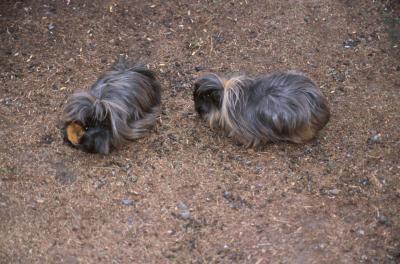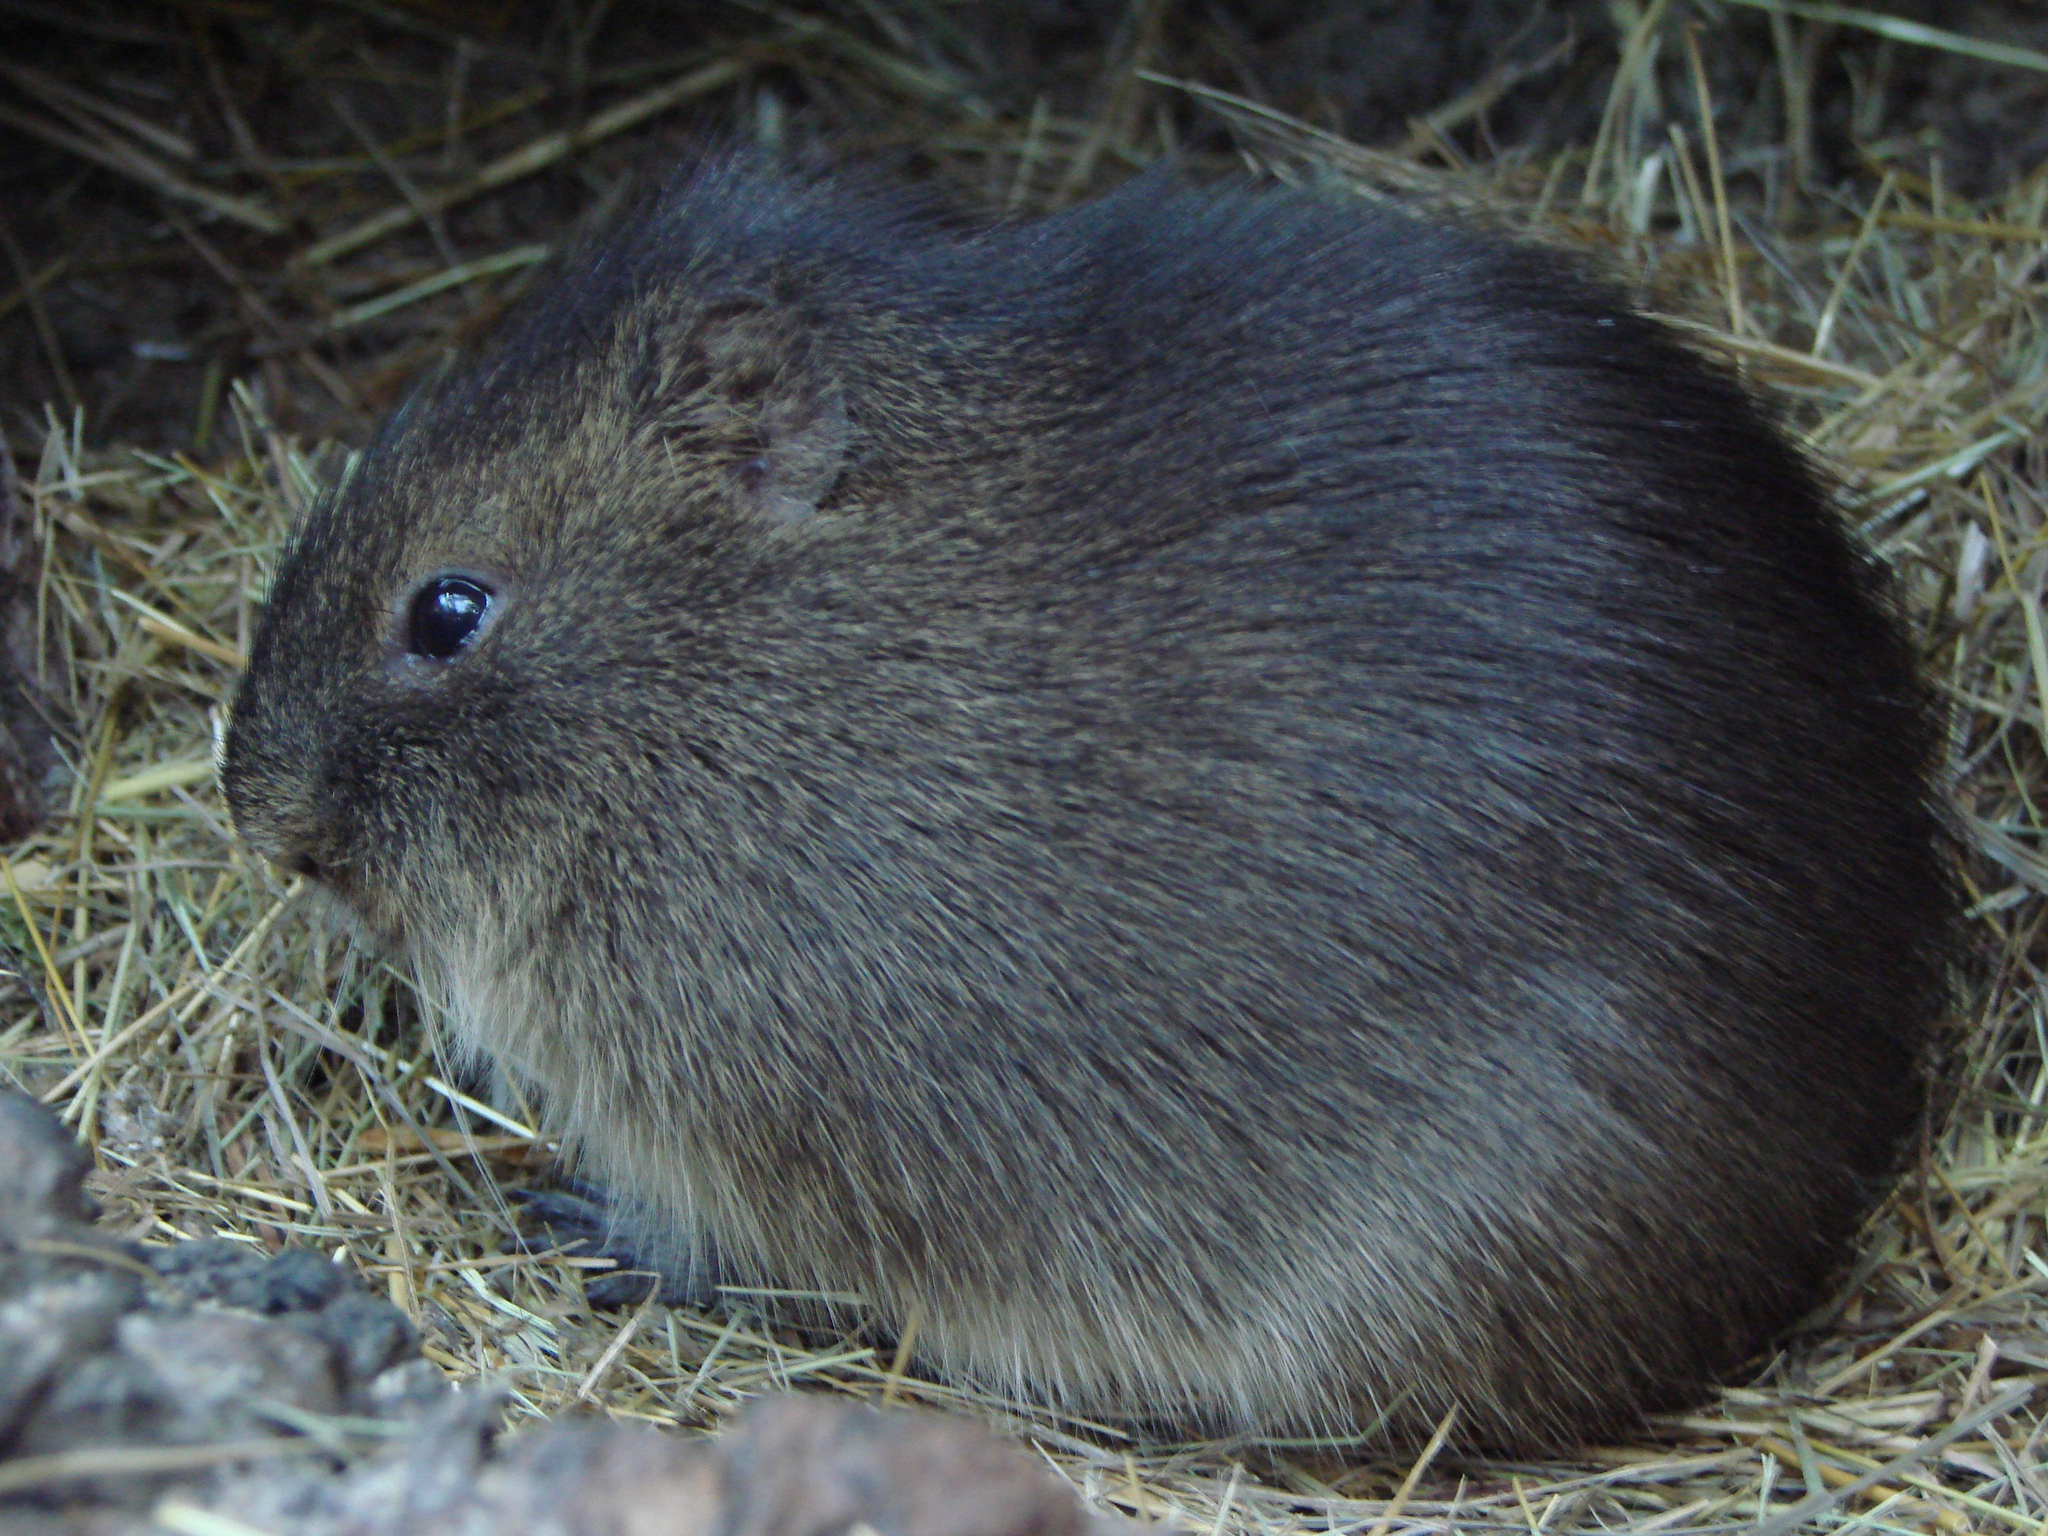The first image is the image on the left, the second image is the image on the right. Assess this claim about the two images: "One of the rodents is sitting still in the green grass.". Correct or not? Answer yes or no. No. 